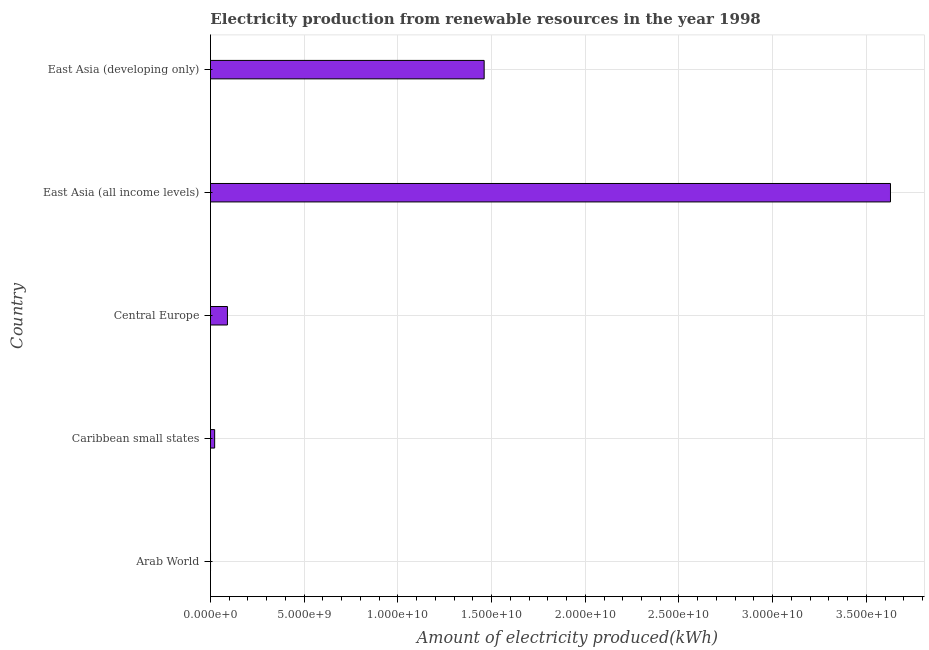Does the graph contain any zero values?
Your answer should be compact. No. Does the graph contain grids?
Ensure brevity in your answer.  Yes. What is the title of the graph?
Your answer should be compact. Electricity production from renewable resources in the year 1998. What is the label or title of the X-axis?
Give a very brief answer. Amount of electricity produced(kWh). What is the amount of electricity produced in East Asia (developing only)?
Provide a short and direct response. 1.46e+1. Across all countries, what is the maximum amount of electricity produced?
Provide a short and direct response. 3.63e+1. In which country was the amount of electricity produced maximum?
Give a very brief answer. East Asia (all income levels). In which country was the amount of electricity produced minimum?
Your response must be concise. Arab World. What is the sum of the amount of electricity produced?
Provide a succinct answer. 5.20e+1. What is the difference between the amount of electricity produced in Arab World and East Asia (all income levels)?
Your answer should be very brief. -3.63e+1. What is the average amount of electricity produced per country?
Ensure brevity in your answer.  1.04e+1. What is the median amount of electricity produced?
Make the answer very short. 9.05e+08. What is the ratio of the amount of electricity produced in Arab World to that in East Asia (all income levels)?
Give a very brief answer. 0. What is the difference between the highest and the second highest amount of electricity produced?
Your response must be concise. 2.17e+1. Is the sum of the amount of electricity produced in East Asia (all income levels) and East Asia (developing only) greater than the maximum amount of electricity produced across all countries?
Your answer should be very brief. Yes. What is the difference between the highest and the lowest amount of electricity produced?
Make the answer very short. 3.63e+1. Are all the bars in the graph horizontal?
Give a very brief answer. Yes. How many countries are there in the graph?
Offer a terse response. 5. What is the difference between two consecutive major ticks on the X-axis?
Your answer should be compact. 5.00e+09. What is the Amount of electricity produced(kWh) in Arab World?
Offer a terse response. 3.00e+06. What is the Amount of electricity produced(kWh) of Caribbean small states?
Ensure brevity in your answer.  2.23e+08. What is the Amount of electricity produced(kWh) of Central Europe?
Offer a very short reply. 9.05e+08. What is the Amount of electricity produced(kWh) in East Asia (all income levels)?
Keep it short and to the point. 3.63e+1. What is the Amount of electricity produced(kWh) in East Asia (developing only)?
Make the answer very short. 1.46e+1. What is the difference between the Amount of electricity produced(kWh) in Arab World and Caribbean small states?
Your answer should be compact. -2.20e+08. What is the difference between the Amount of electricity produced(kWh) in Arab World and Central Europe?
Provide a succinct answer. -9.02e+08. What is the difference between the Amount of electricity produced(kWh) in Arab World and East Asia (all income levels)?
Your answer should be compact. -3.63e+1. What is the difference between the Amount of electricity produced(kWh) in Arab World and East Asia (developing only)?
Your answer should be compact. -1.46e+1. What is the difference between the Amount of electricity produced(kWh) in Caribbean small states and Central Europe?
Your response must be concise. -6.82e+08. What is the difference between the Amount of electricity produced(kWh) in Caribbean small states and East Asia (all income levels)?
Provide a short and direct response. -3.61e+1. What is the difference between the Amount of electricity produced(kWh) in Caribbean small states and East Asia (developing only)?
Ensure brevity in your answer.  -1.44e+1. What is the difference between the Amount of electricity produced(kWh) in Central Europe and East Asia (all income levels)?
Your response must be concise. -3.54e+1. What is the difference between the Amount of electricity produced(kWh) in Central Europe and East Asia (developing only)?
Provide a succinct answer. -1.37e+1. What is the difference between the Amount of electricity produced(kWh) in East Asia (all income levels) and East Asia (developing only)?
Your response must be concise. 2.17e+1. What is the ratio of the Amount of electricity produced(kWh) in Arab World to that in Caribbean small states?
Make the answer very short. 0.01. What is the ratio of the Amount of electricity produced(kWh) in Arab World to that in Central Europe?
Provide a short and direct response. 0. What is the ratio of the Amount of electricity produced(kWh) in Arab World to that in East Asia (all income levels)?
Your answer should be very brief. 0. What is the ratio of the Amount of electricity produced(kWh) in Caribbean small states to that in Central Europe?
Your answer should be very brief. 0.25. What is the ratio of the Amount of electricity produced(kWh) in Caribbean small states to that in East Asia (all income levels)?
Offer a terse response. 0.01. What is the ratio of the Amount of electricity produced(kWh) in Caribbean small states to that in East Asia (developing only)?
Offer a very short reply. 0.01. What is the ratio of the Amount of electricity produced(kWh) in Central Europe to that in East Asia (all income levels)?
Keep it short and to the point. 0.03. What is the ratio of the Amount of electricity produced(kWh) in Central Europe to that in East Asia (developing only)?
Keep it short and to the point. 0.06. What is the ratio of the Amount of electricity produced(kWh) in East Asia (all income levels) to that in East Asia (developing only)?
Give a very brief answer. 2.48. 